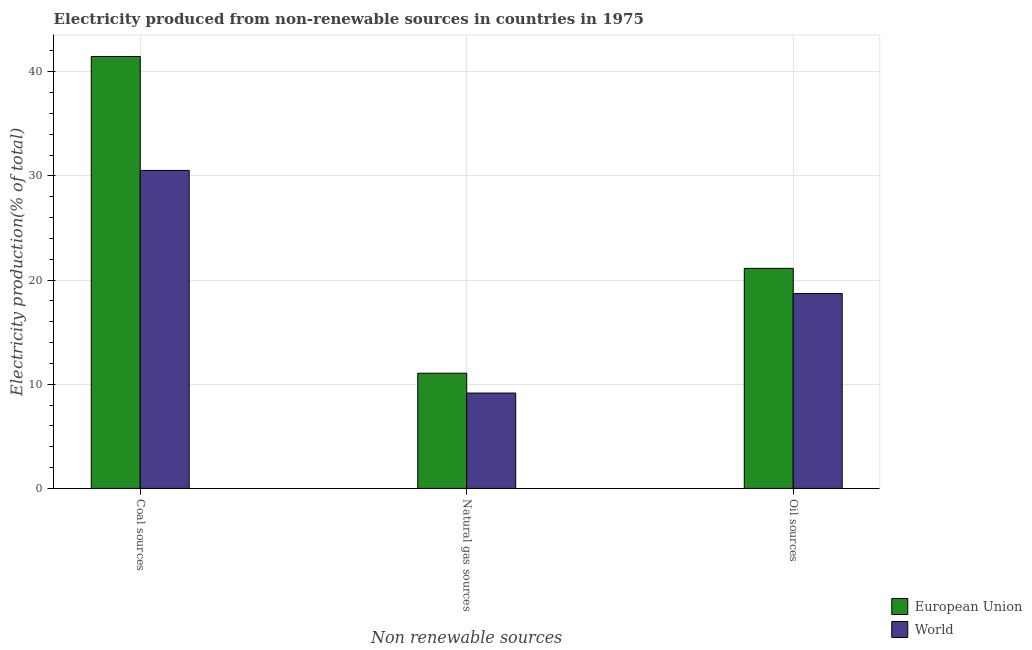How many different coloured bars are there?
Offer a very short reply. 2. How many groups of bars are there?
Make the answer very short. 3. Are the number of bars per tick equal to the number of legend labels?
Provide a short and direct response. Yes. How many bars are there on the 1st tick from the right?
Your response must be concise. 2. What is the label of the 3rd group of bars from the left?
Offer a terse response. Oil sources. What is the percentage of electricity produced by natural gas in European Union?
Offer a terse response. 11.06. Across all countries, what is the maximum percentage of electricity produced by coal?
Give a very brief answer. 41.46. Across all countries, what is the minimum percentage of electricity produced by coal?
Offer a terse response. 30.52. In which country was the percentage of electricity produced by natural gas maximum?
Ensure brevity in your answer.  European Union. What is the total percentage of electricity produced by natural gas in the graph?
Provide a succinct answer. 20.21. What is the difference between the percentage of electricity produced by coal in European Union and that in World?
Provide a succinct answer. 10.94. What is the difference between the percentage of electricity produced by coal in European Union and the percentage of electricity produced by natural gas in World?
Provide a succinct answer. 32.3. What is the average percentage of electricity produced by oil sources per country?
Make the answer very short. 19.91. What is the difference between the percentage of electricity produced by natural gas and percentage of electricity produced by oil sources in World?
Make the answer very short. -9.55. In how many countries, is the percentage of electricity produced by natural gas greater than 6 %?
Provide a succinct answer. 2. What is the ratio of the percentage of electricity produced by coal in European Union to that in World?
Ensure brevity in your answer.  1.36. Is the percentage of electricity produced by coal in European Union less than that in World?
Your response must be concise. No. Is the difference between the percentage of electricity produced by natural gas in European Union and World greater than the difference between the percentage of electricity produced by coal in European Union and World?
Provide a succinct answer. No. What is the difference between the highest and the second highest percentage of electricity produced by oil sources?
Keep it short and to the point. 2.41. What is the difference between the highest and the lowest percentage of electricity produced by coal?
Give a very brief answer. 10.94. Is the sum of the percentage of electricity produced by oil sources in World and European Union greater than the maximum percentage of electricity produced by natural gas across all countries?
Give a very brief answer. Yes. What does the 1st bar from the left in Natural gas sources represents?
Provide a succinct answer. European Union. How many bars are there?
Your response must be concise. 6. Are all the bars in the graph horizontal?
Provide a succinct answer. No. Where does the legend appear in the graph?
Provide a short and direct response. Bottom right. How many legend labels are there?
Make the answer very short. 2. What is the title of the graph?
Offer a terse response. Electricity produced from non-renewable sources in countries in 1975. Does "Somalia" appear as one of the legend labels in the graph?
Your response must be concise. No. What is the label or title of the X-axis?
Your response must be concise. Non renewable sources. What is the label or title of the Y-axis?
Provide a short and direct response. Electricity production(% of total). What is the Electricity production(% of total) in European Union in Coal sources?
Ensure brevity in your answer.  41.46. What is the Electricity production(% of total) in World in Coal sources?
Offer a very short reply. 30.52. What is the Electricity production(% of total) of European Union in Natural gas sources?
Make the answer very short. 11.06. What is the Electricity production(% of total) of World in Natural gas sources?
Offer a very short reply. 9.15. What is the Electricity production(% of total) of European Union in Oil sources?
Your answer should be compact. 21.12. What is the Electricity production(% of total) of World in Oil sources?
Your response must be concise. 18.71. Across all Non renewable sources, what is the maximum Electricity production(% of total) of European Union?
Provide a succinct answer. 41.46. Across all Non renewable sources, what is the maximum Electricity production(% of total) in World?
Offer a very short reply. 30.52. Across all Non renewable sources, what is the minimum Electricity production(% of total) in European Union?
Keep it short and to the point. 11.06. Across all Non renewable sources, what is the minimum Electricity production(% of total) of World?
Give a very brief answer. 9.15. What is the total Electricity production(% of total) of European Union in the graph?
Ensure brevity in your answer.  73.63. What is the total Electricity production(% of total) in World in the graph?
Offer a very short reply. 58.38. What is the difference between the Electricity production(% of total) in European Union in Coal sources and that in Natural gas sources?
Provide a short and direct response. 30.4. What is the difference between the Electricity production(% of total) of World in Coal sources and that in Natural gas sources?
Give a very brief answer. 21.37. What is the difference between the Electricity production(% of total) in European Union in Coal sources and that in Oil sources?
Offer a very short reply. 20.34. What is the difference between the Electricity production(% of total) of World in Coal sources and that in Oil sources?
Provide a succinct answer. 11.81. What is the difference between the Electricity production(% of total) in European Union in Natural gas sources and that in Oil sources?
Your response must be concise. -10.06. What is the difference between the Electricity production(% of total) in World in Natural gas sources and that in Oil sources?
Make the answer very short. -9.55. What is the difference between the Electricity production(% of total) of European Union in Coal sources and the Electricity production(% of total) of World in Natural gas sources?
Offer a terse response. 32.3. What is the difference between the Electricity production(% of total) in European Union in Coal sources and the Electricity production(% of total) in World in Oil sources?
Ensure brevity in your answer.  22.75. What is the difference between the Electricity production(% of total) in European Union in Natural gas sources and the Electricity production(% of total) in World in Oil sources?
Provide a succinct answer. -7.65. What is the average Electricity production(% of total) in European Union per Non renewable sources?
Your response must be concise. 24.54. What is the average Electricity production(% of total) in World per Non renewable sources?
Your answer should be very brief. 19.46. What is the difference between the Electricity production(% of total) in European Union and Electricity production(% of total) in World in Coal sources?
Provide a succinct answer. 10.94. What is the difference between the Electricity production(% of total) of European Union and Electricity production(% of total) of World in Natural gas sources?
Provide a succinct answer. 1.91. What is the difference between the Electricity production(% of total) in European Union and Electricity production(% of total) in World in Oil sources?
Provide a short and direct response. 2.41. What is the ratio of the Electricity production(% of total) of European Union in Coal sources to that in Natural gas sources?
Your answer should be very brief. 3.75. What is the ratio of the Electricity production(% of total) of World in Coal sources to that in Natural gas sources?
Give a very brief answer. 3.33. What is the ratio of the Electricity production(% of total) of European Union in Coal sources to that in Oil sources?
Give a very brief answer. 1.96. What is the ratio of the Electricity production(% of total) in World in Coal sources to that in Oil sources?
Provide a short and direct response. 1.63. What is the ratio of the Electricity production(% of total) in European Union in Natural gas sources to that in Oil sources?
Offer a terse response. 0.52. What is the ratio of the Electricity production(% of total) in World in Natural gas sources to that in Oil sources?
Offer a terse response. 0.49. What is the difference between the highest and the second highest Electricity production(% of total) of European Union?
Your answer should be compact. 20.34. What is the difference between the highest and the second highest Electricity production(% of total) in World?
Give a very brief answer. 11.81. What is the difference between the highest and the lowest Electricity production(% of total) of European Union?
Provide a short and direct response. 30.4. What is the difference between the highest and the lowest Electricity production(% of total) in World?
Make the answer very short. 21.37. 